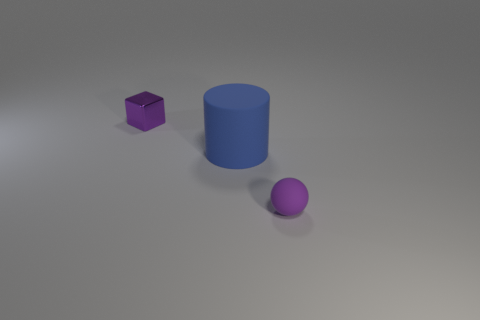How are shadows cast in this image, and what does that tell us about the light source? The shadows are cast diagonally towards the bottom right, suggesting that the light source is positioned upper left relative to the objects. The soft edges of the shadows indicate the light source is not extremely close to the objects or very intense. 